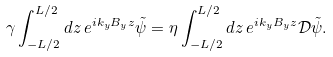Convert formula to latex. <formula><loc_0><loc_0><loc_500><loc_500>\gamma \int _ { - L / 2 } ^ { L / 2 } d z \, e ^ { i k _ { y } B _ { y } z } \tilde { \psi } = \eta \int _ { - L / 2 } ^ { L / 2 } d z \, e ^ { i k _ { y } B _ { y } z } \mathcal { D } \tilde { \psi } .</formula> 